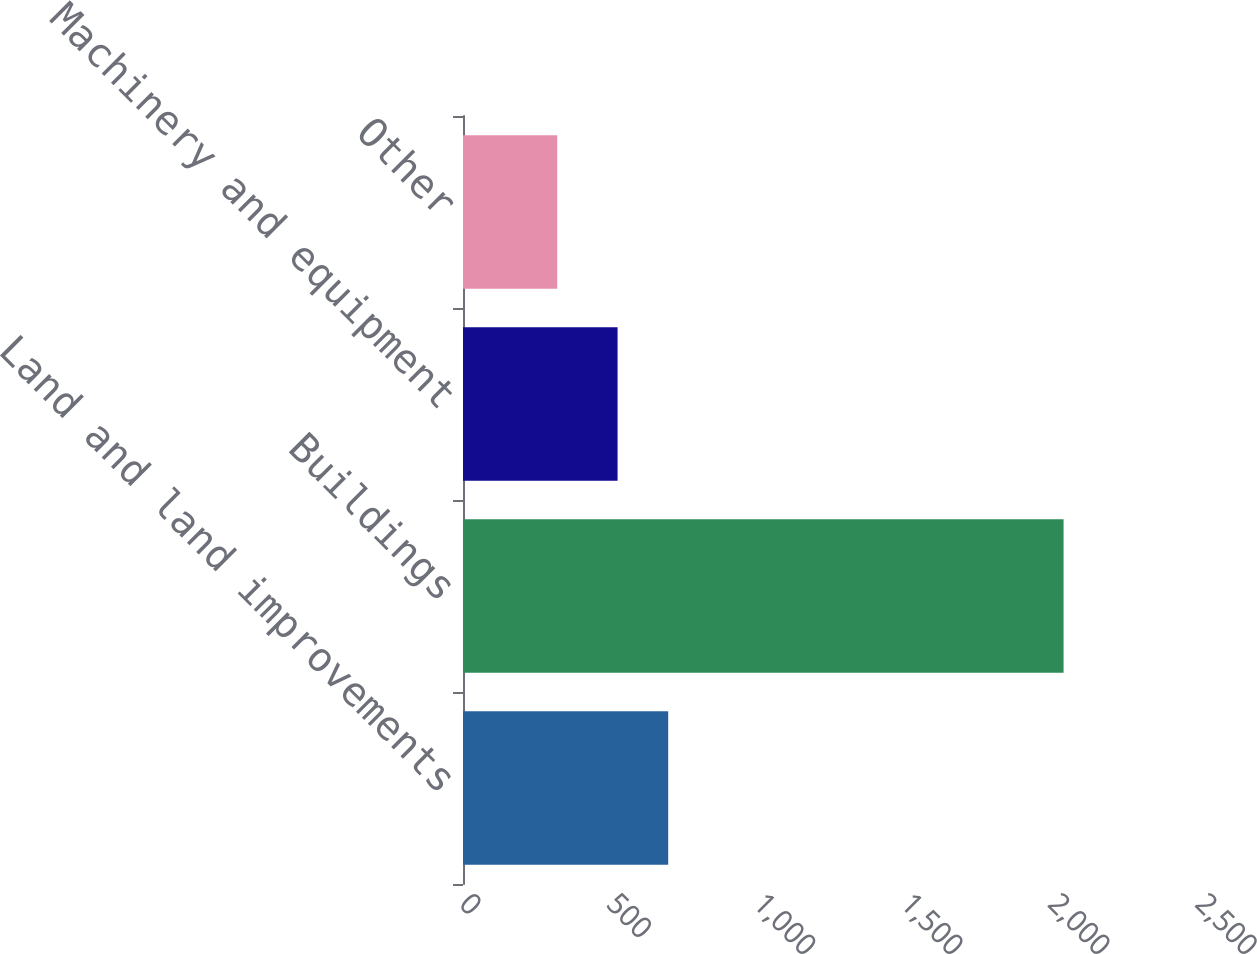<chart> <loc_0><loc_0><loc_500><loc_500><bar_chart><fcel>Land and land improvements<fcel>Buildings<fcel>Machinery and equipment<fcel>Other<nl><fcel>697<fcel>2040<fcel>525<fcel>320<nl></chart> 